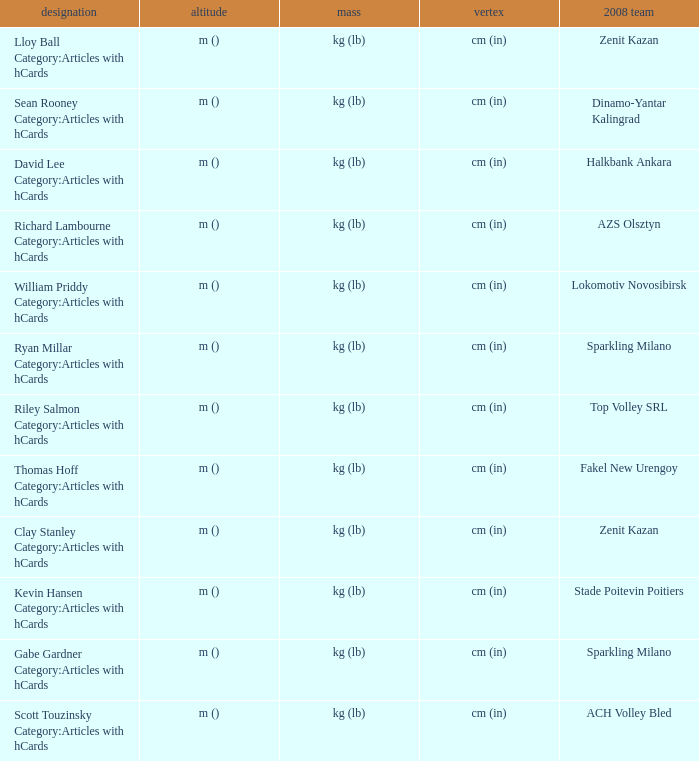What is the name for the 2008 club of Azs olsztyn? Richard Lambourne Category:Articles with hCards. 